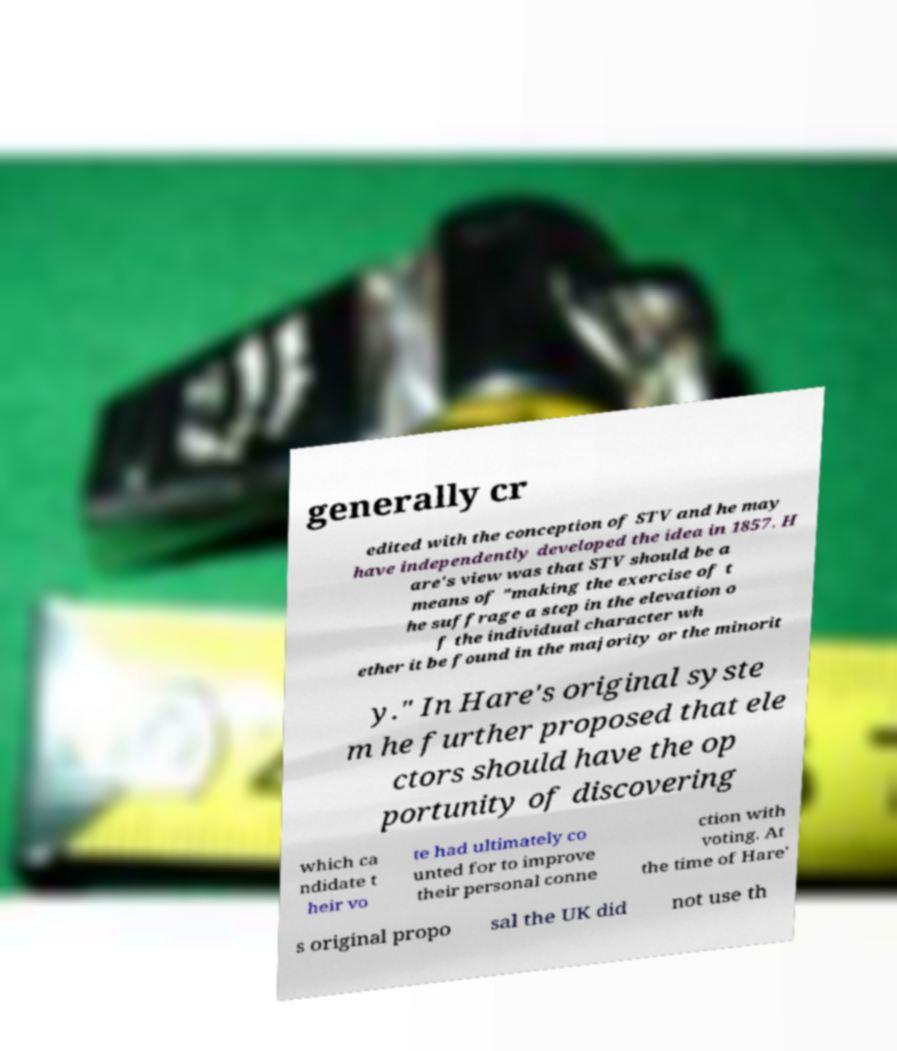Can you read and provide the text displayed in the image?This photo seems to have some interesting text. Can you extract and type it out for me? generally cr edited with the conception of STV and he may have independently developed the idea in 1857. H are's view was that STV should be a means of "making the exercise of t he suffrage a step in the elevation o f the individual character wh ether it be found in the majority or the minorit y." In Hare's original syste m he further proposed that ele ctors should have the op portunity of discovering which ca ndidate t heir vo te had ultimately co unted for to improve their personal conne ction with voting. At the time of Hare' s original propo sal the UK did not use th 